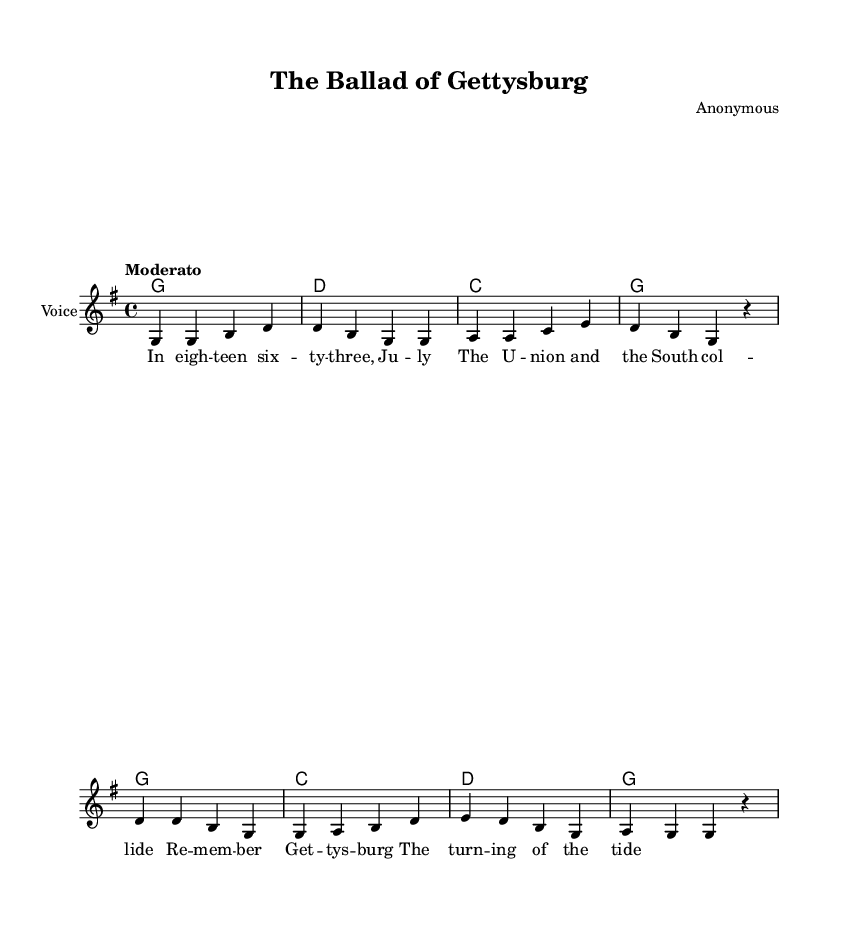What is the key signature of this music? The key signature is G major, which has one sharp (F#). It can be identified by looking at the left side of the staff where the sharps and flats are notated.
Answer: G major What is the time signature of this music? The time signature is 4/4, which indicates four beats per measure and a quarter note receives one beat. This can be found at the beginning of the sheet music after the key signature.
Answer: 4/4 What tempo marking is used in this piece? The tempo marking is "Moderato," which indicates a moderate speed of the music. This marking is typically located at the beginning of the score, following the time signature.
Answer: Moderato How many measures are there in the melody? The melody consists of 8 measures, which can be counted by looking at the vertical bar lines that divide the music into sections. Each bar line indicates the end of a measure.
Answer: 8 What is the title of this ballad? The title of the ballad is "The Ballad of Gettysburg," and it is specified at the top of the sheet music as part of the header information.
Answer: The Ballad of Gettysburg Who is the composer of this music? The composer is listed as "Anonymous," which indicates that the author of the song is unknown. This information is also found in the header section of the sheet music.
Answer: Anonymous What notable historical event does this ballad recount? This ballad recounts the Battle of Gettysburg, a pivotal battle during the American Civil War. The lyrics reference this event explicitly in the verse.
Answer: Battle of Gettysburg 